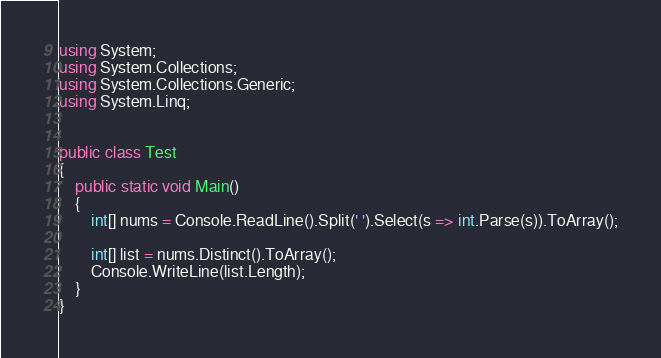<code> <loc_0><loc_0><loc_500><loc_500><_C#_>using System;
using System.Collections;
using System.Collections.Generic;
using System.Linq;


public class Test
{	
    public static void Main()
	{
        int[] nums = Console.ReadLine().Split(' ').Select(s => int.Parse(s)).ToArray();
        
        int[] list = nums.Distinct().ToArray();
	    Console.WriteLine(list.Length);
	}
}</code> 